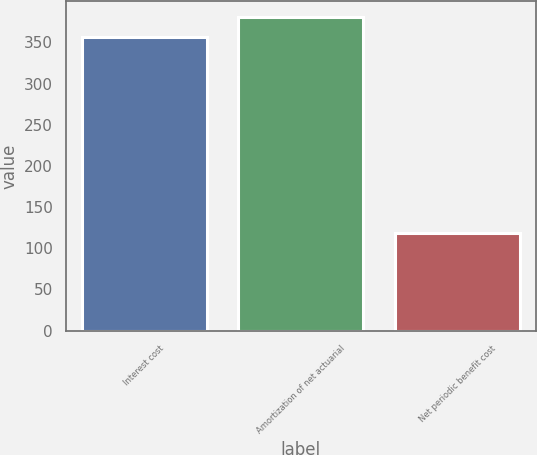Convert chart. <chart><loc_0><loc_0><loc_500><loc_500><bar_chart><fcel>Interest cost<fcel>Amortization of net actuarial<fcel>Net periodic benefit cost<nl><fcel>357<fcel>380.9<fcel>118<nl></chart> 